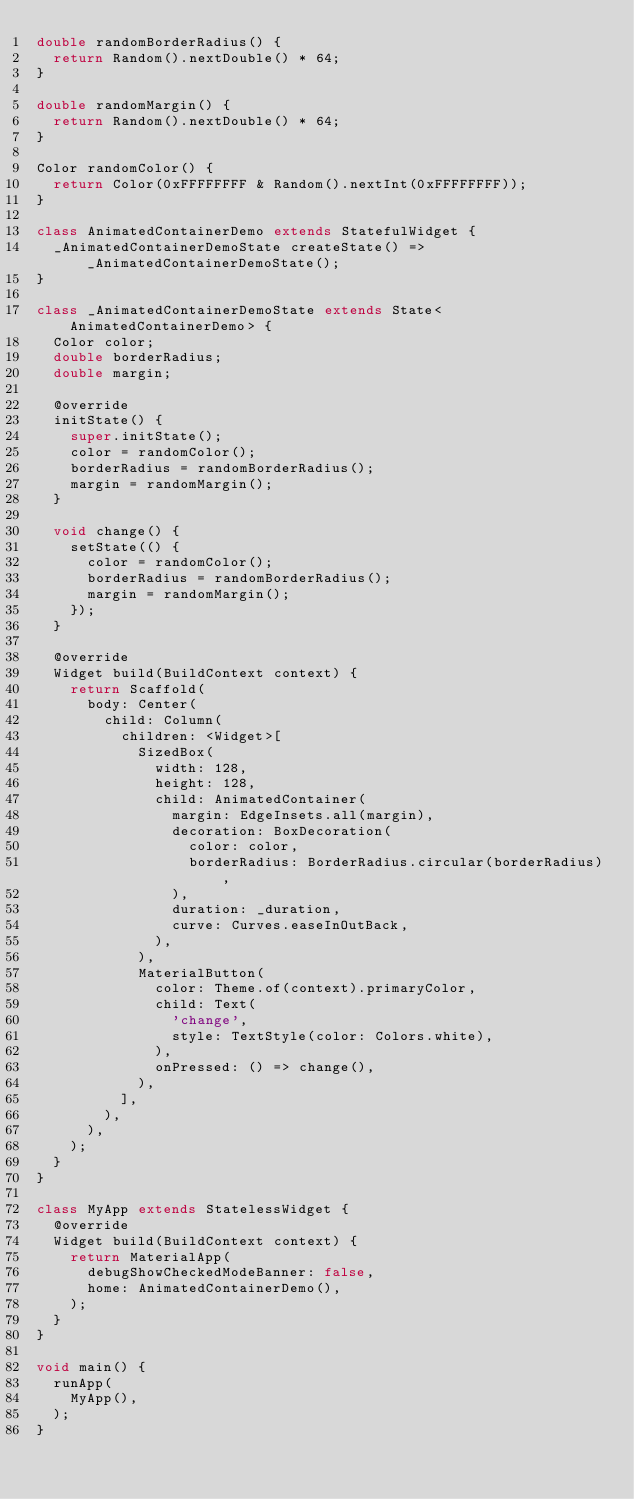Convert code to text. <code><loc_0><loc_0><loc_500><loc_500><_Dart_>double randomBorderRadius() {
  return Random().nextDouble() * 64;
}

double randomMargin() {
  return Random().nextDouble() * 64;
}

Color randomColor() {
  return Color(0xFFFFFFFF & Random().nextInt(0xFFFFFFFF));
}

class AnimatedContainerDemo extends StatefulWidget {
  _AnimatedContainerDemoState createState() => _AnimatedContainerDemoState();
}

class _AnimatedContainerDemoState extends State<AnimatedContainerDemo> {
  Color color;
  double borderRadius;
  double margin;

  @override
  initState() {
    super.initState();
    color = randomColor();
    borderRadius = randomBorderRadius();
    margin = randomMargin();
  }

  void change() {
    setState(() {
      color = randomColor();
      borderRadius = randomBorderRadius();
      margin = randomMargin();
    });
  }

  @override
  Widget build(BuildContext context) {
    return Scaffold(
      body: Center(
        child: Column(
          children: <Widget>[
            SizedBox(
              width: 128,
              height: 128,
              child: AnimatedContainer(
                margin: EdgeInsets.all(margin),
                decoration: BoxDecoration(
                  color: color,
                  borderRadius: BorderRadius.circular(borderRadius),
                ),
                duration: _duration,
                curve: Curves.easeInOutBack,
              ),
            ),
            MaterialButton(
              color: Theme.of(context).primaryColor,
              child: Text(
                'change',
                style: TextStyle(color: Colors.white),
              ),
              onPressed: () => change(),
            ),
          ],
        ),
      ),
    );
  }
}

class MyApp extends StatelessWidget {
  @override
  Widget build(BuildContext context) {
    return MaterialApp(
      debugShowCheckedModeBanner: false,
      home: AnimatedContainerDemo(),
    );
  }
}

void main() {
  runApp(
    MyApp(),
  );
}
</code> 